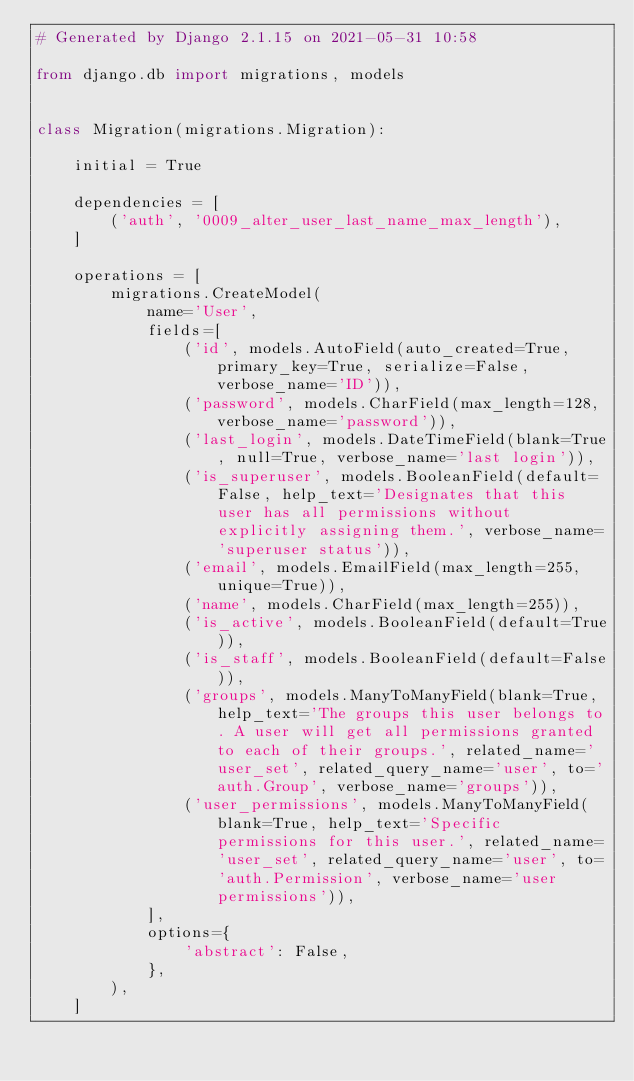<code> <loc_0><loc_0><loc_500><loc_500><_Python_># Generated by Django 2.1.15 on 2021-05-31 10:58

from django.db import migrations, models


class Migration(migrations.Migration):

    initial = True

    dependencies = [
        ('auth', '0009_alter_user_last_name_max_length'),
    ]

    operations = [
        migrations.CreateModel(
            name='User',
            fields=[
                ('id', models.AutoField(auto_created=True, primary_key=True, serialize=False, verbose_name='ID')),
                ('password', models.CharField(max_length=128, verbose_name='password')),
                ('last_login', models.DateTimeField(blank=True, null=True, verbose_name='last login')),
                ('is_superuser', models.BooleanField(default=False, help_text='Designates that this user has all permissions without explicitly assigning them.', verbose_name='superuser status')),
                ('email', models.EmailField(max_length=255, unique=True)),
                ('name', models.CharField(max_length=255)),
                ('is_active', models.BooleanField(default=True)),
                ('is_staff', models.BooleanField(default=False)),
                ('groups', models.ManyToManyField(blank=True, help_text='The groups this user belongs to. A user will get all permissions granted to each of their groups.', related_name='user_set', related_query_name='user', to='auth.Group', verbose_name='groups')),
                ('user_permissions', models.ManyToManyField(blank=True, help_text='Specific permissions for this user.', related_name='user_set', related_query_name='user', to='auth.Permission', verbose_name='user permissions')),
            ],
            options={
                'abstract': False,
            },
        ),
    ]
</code> 